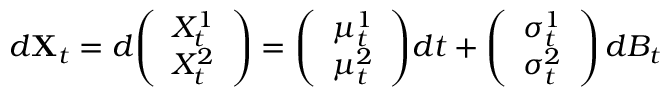Convert formula to latex. <formula><loc_0><loc_0><loc_500><loc_500>d X _ { t } = d { \left ( \begin{array} { l } { X _ { t } ^ { 1 } } \\ { X _ { t } ^ { 2 } } \end{array} \right ) } = { \left ( \begin{array} { l } { \mu _ { t } ^ { 1 } } \\ { \mu _ { t } ^ { 2 } } \end{array} \right ) } d t + { \left ( \begin{array} { l } { \sigma _ { t } ^ { 1 } } \\ { \sigma _ { t } ^ { 2 } } \end{array} \right ) } \, d B _ { t }</formula> 